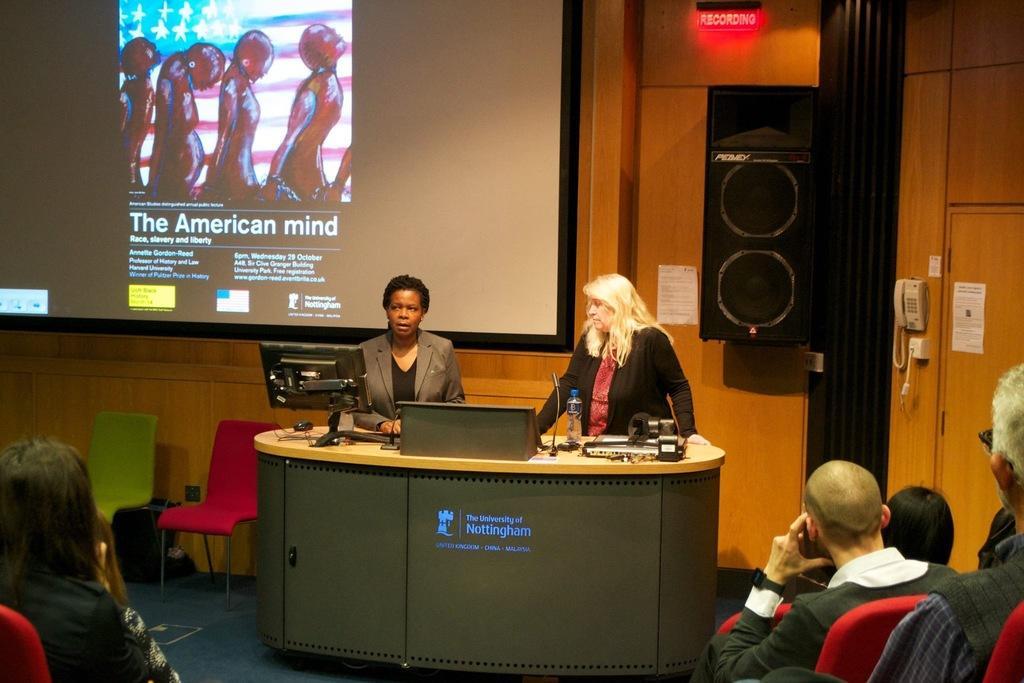Could you give a brief overview of what you see in this image? In this picture there are two women standing behind the desk. On the desk there is a water bottle, mic, computer screen, mouse and other material. On the bottom right corner there is a group of people who is sitting on a chair. This man wears a goggles. On the left bottom corner we can see a woman sitting on a chair. On the background we can see a projector which showing a cartoons and we can read that 'the american mind'. Beside that there is a speaker which is attached to the wall. On the right side there is a telephone. 